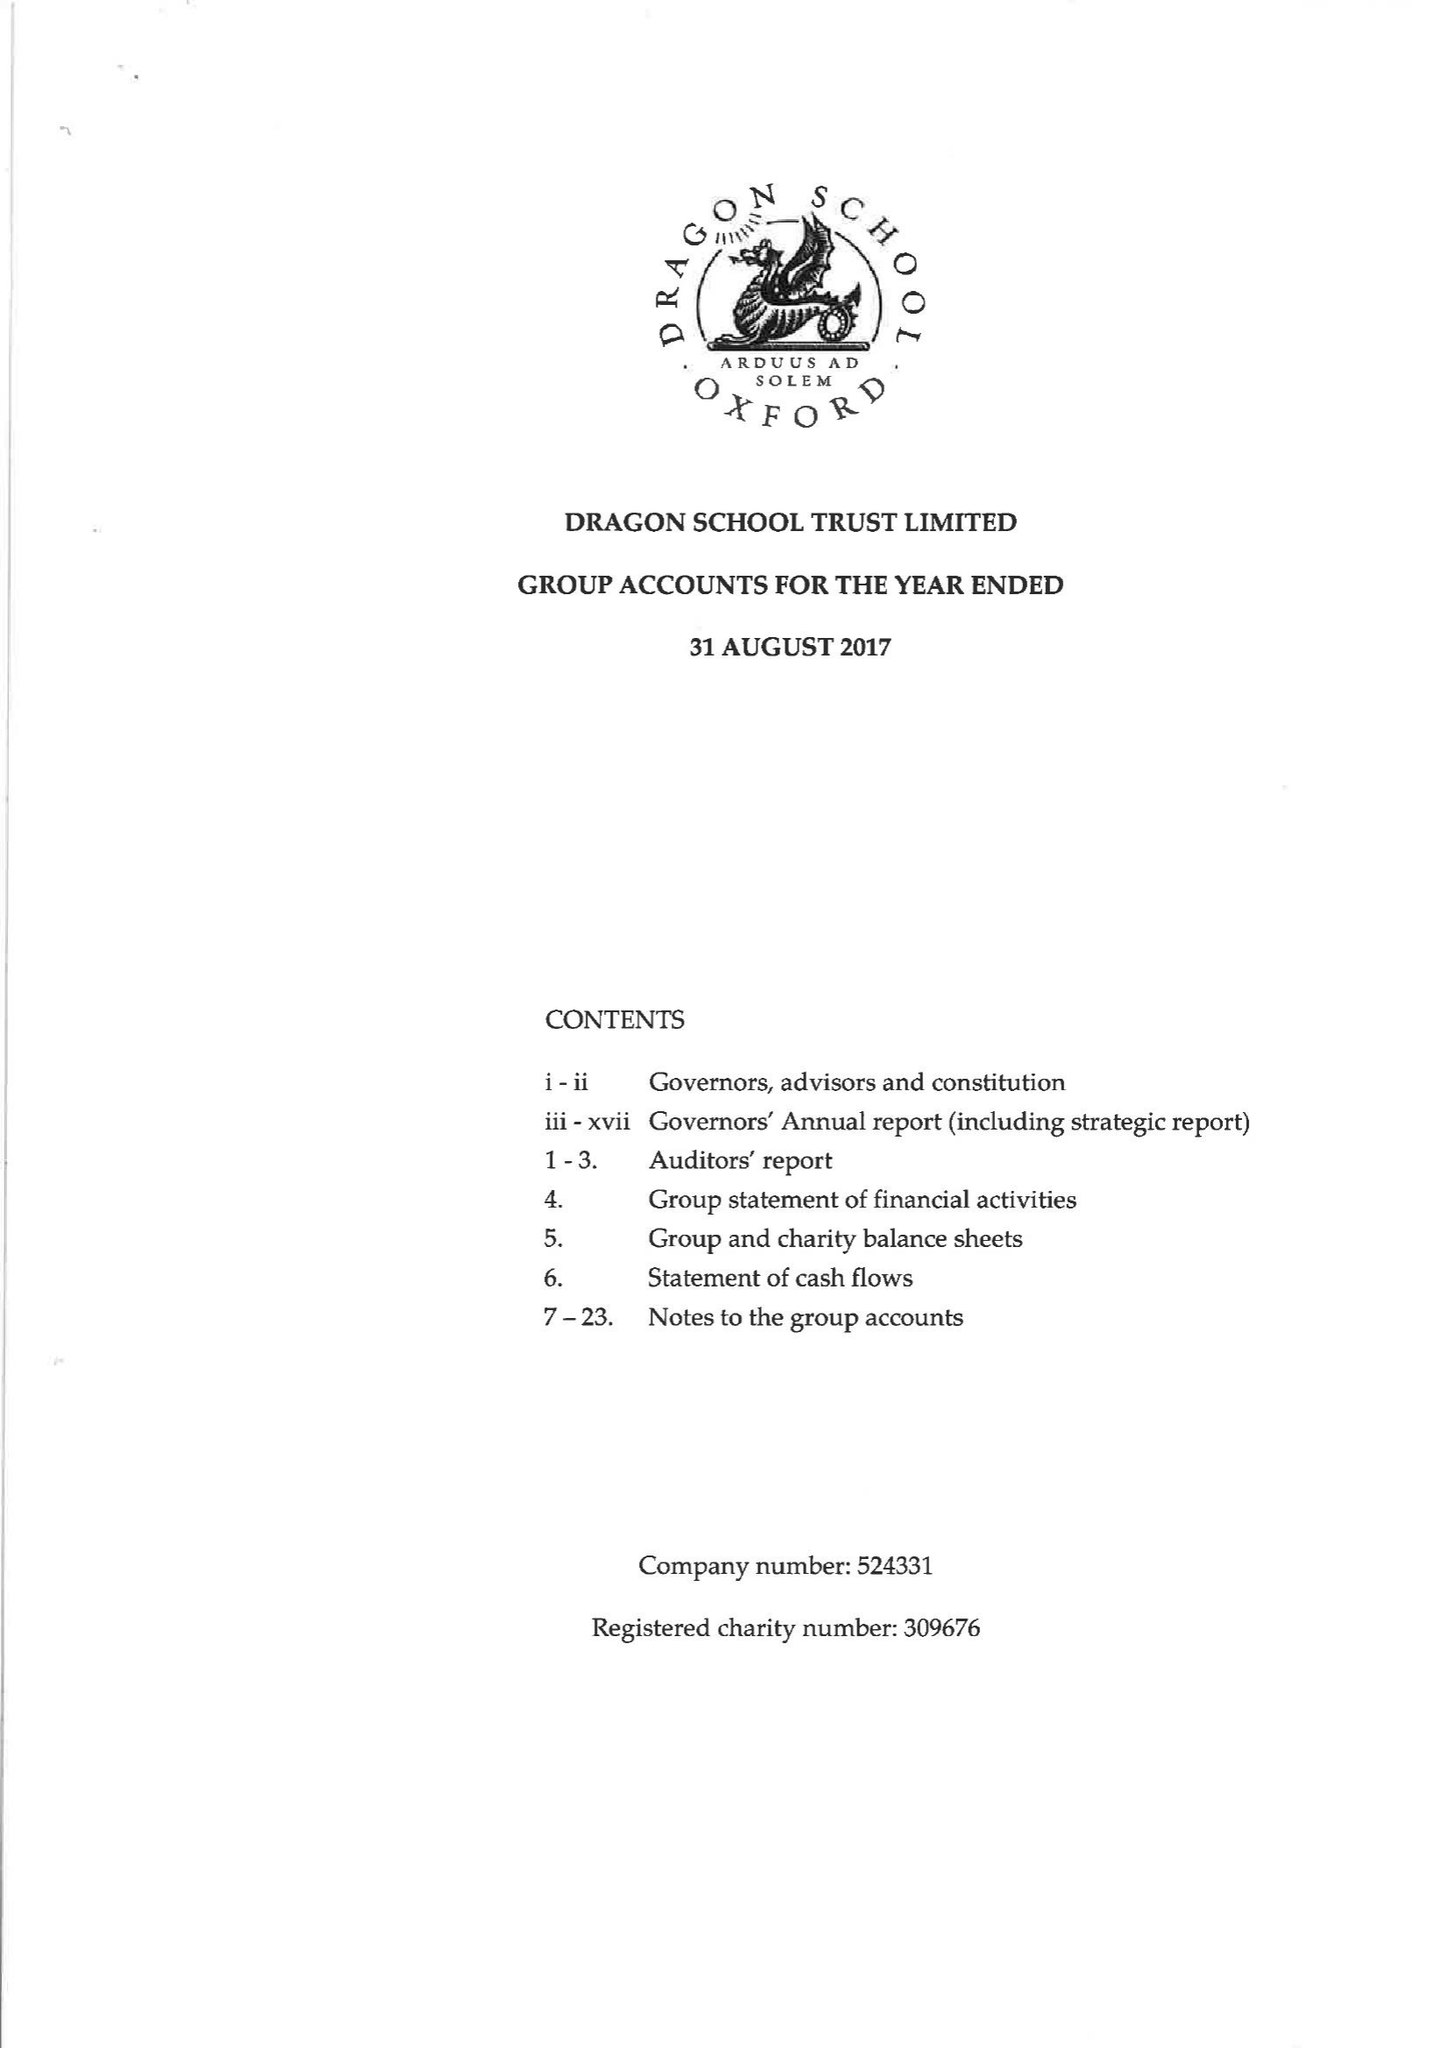What is the value for the address__post_town?
Answer the question using a single word or phrase. OXFORD 